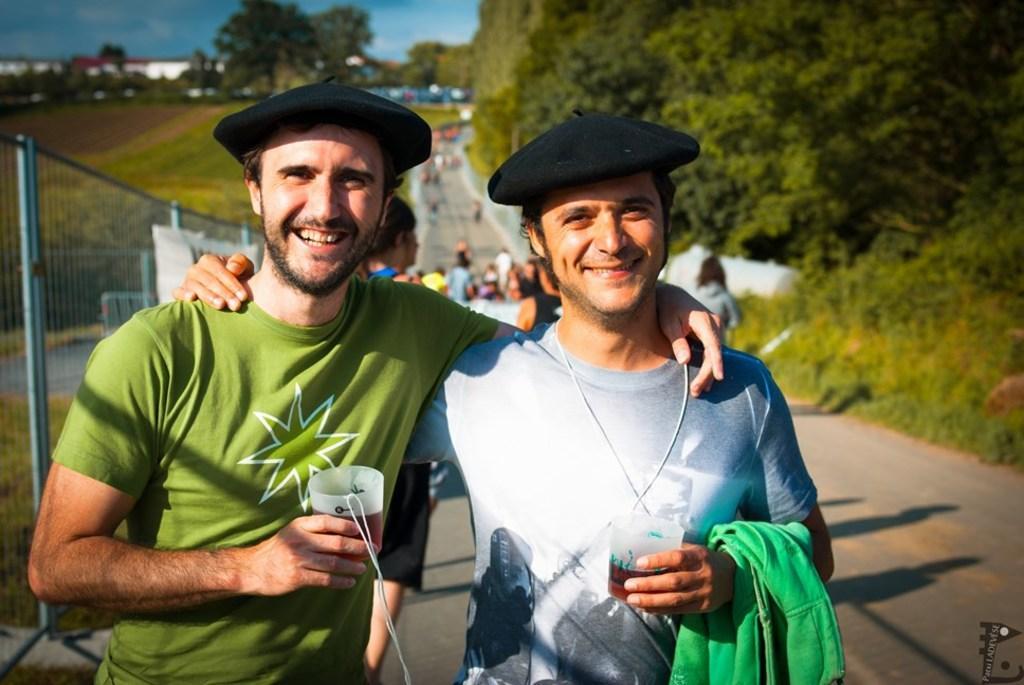Can you describe this image briefly? Here we can see two men. They are holding glasses with their hands and they are smiling. This is a road and there are is fence. In the background we can see group of people, plants, trees, houses, and sky. 